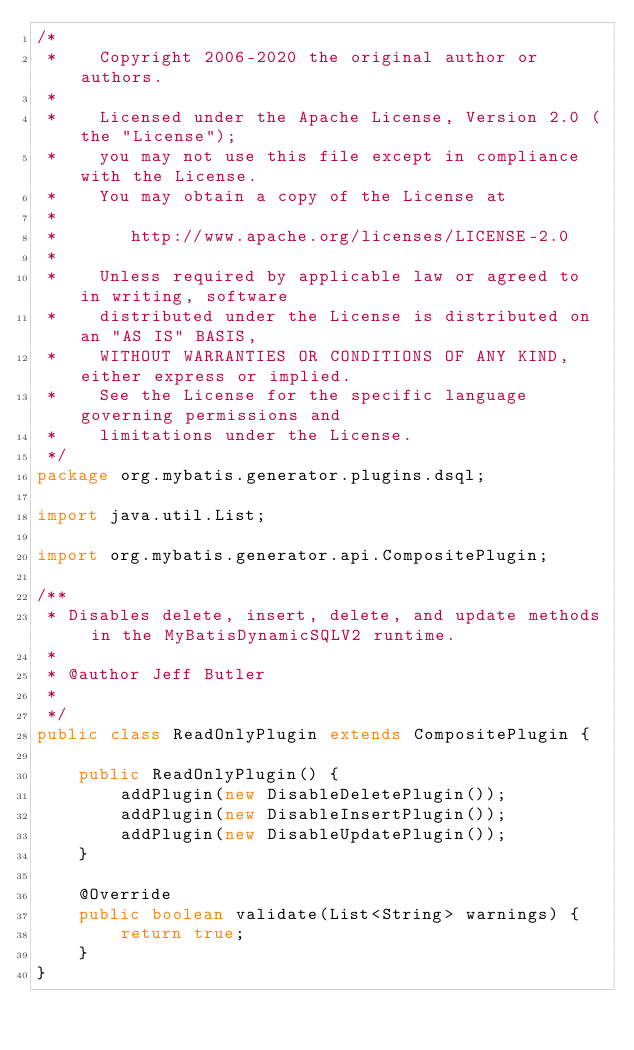<code> <loc_0><loc_0><loc_500><loc_500><_Java_>/*
 *    Copyright 2006-2020 the original author or authors.
 *
 *    Licensed under the Apache License, Version 2.0 (the "License");
 *    you may not use this file except in compliance with the License.
 *    You may obtain a copy of the License at
 *
 *       http://www.apache.org/licenses/LICENSE-2.0
 *
 *    Unless required by applicable law or agreed to in writing, software
 *    distributed under the License is distributed on an "AS IS" BASIS,
 *    WITHOUT WARRANTIES OR CONDITIONS OF ANY KIND, either express or implied.
 *    See the License for the specific language governing permissions and
 *    limitations under the License.
 */
package org.mybatis.generator.plugins.dsql;

import java.util.List;

import org.mybatis.generator.api.CompositePlugin;

/**
 * Disables delete, insert, delete, and update methods in the MyBatisDynamicSQLV2 runtime.
 *
 * @author Jeff Butler
 *
 */
public class ReadOnlyPlugin extends CompositePlugin {

    public ReadOnlyPlugin() {
        addPlugin(new DisableDeletePlugin());
        addPlugin(new DisableInsertPlugin());
        addPlugin(new DisableUpdatePlugin());
    }

    @Override
    public boolean validate(List<String> warnings) {
        return true;
    }
}
</code> 